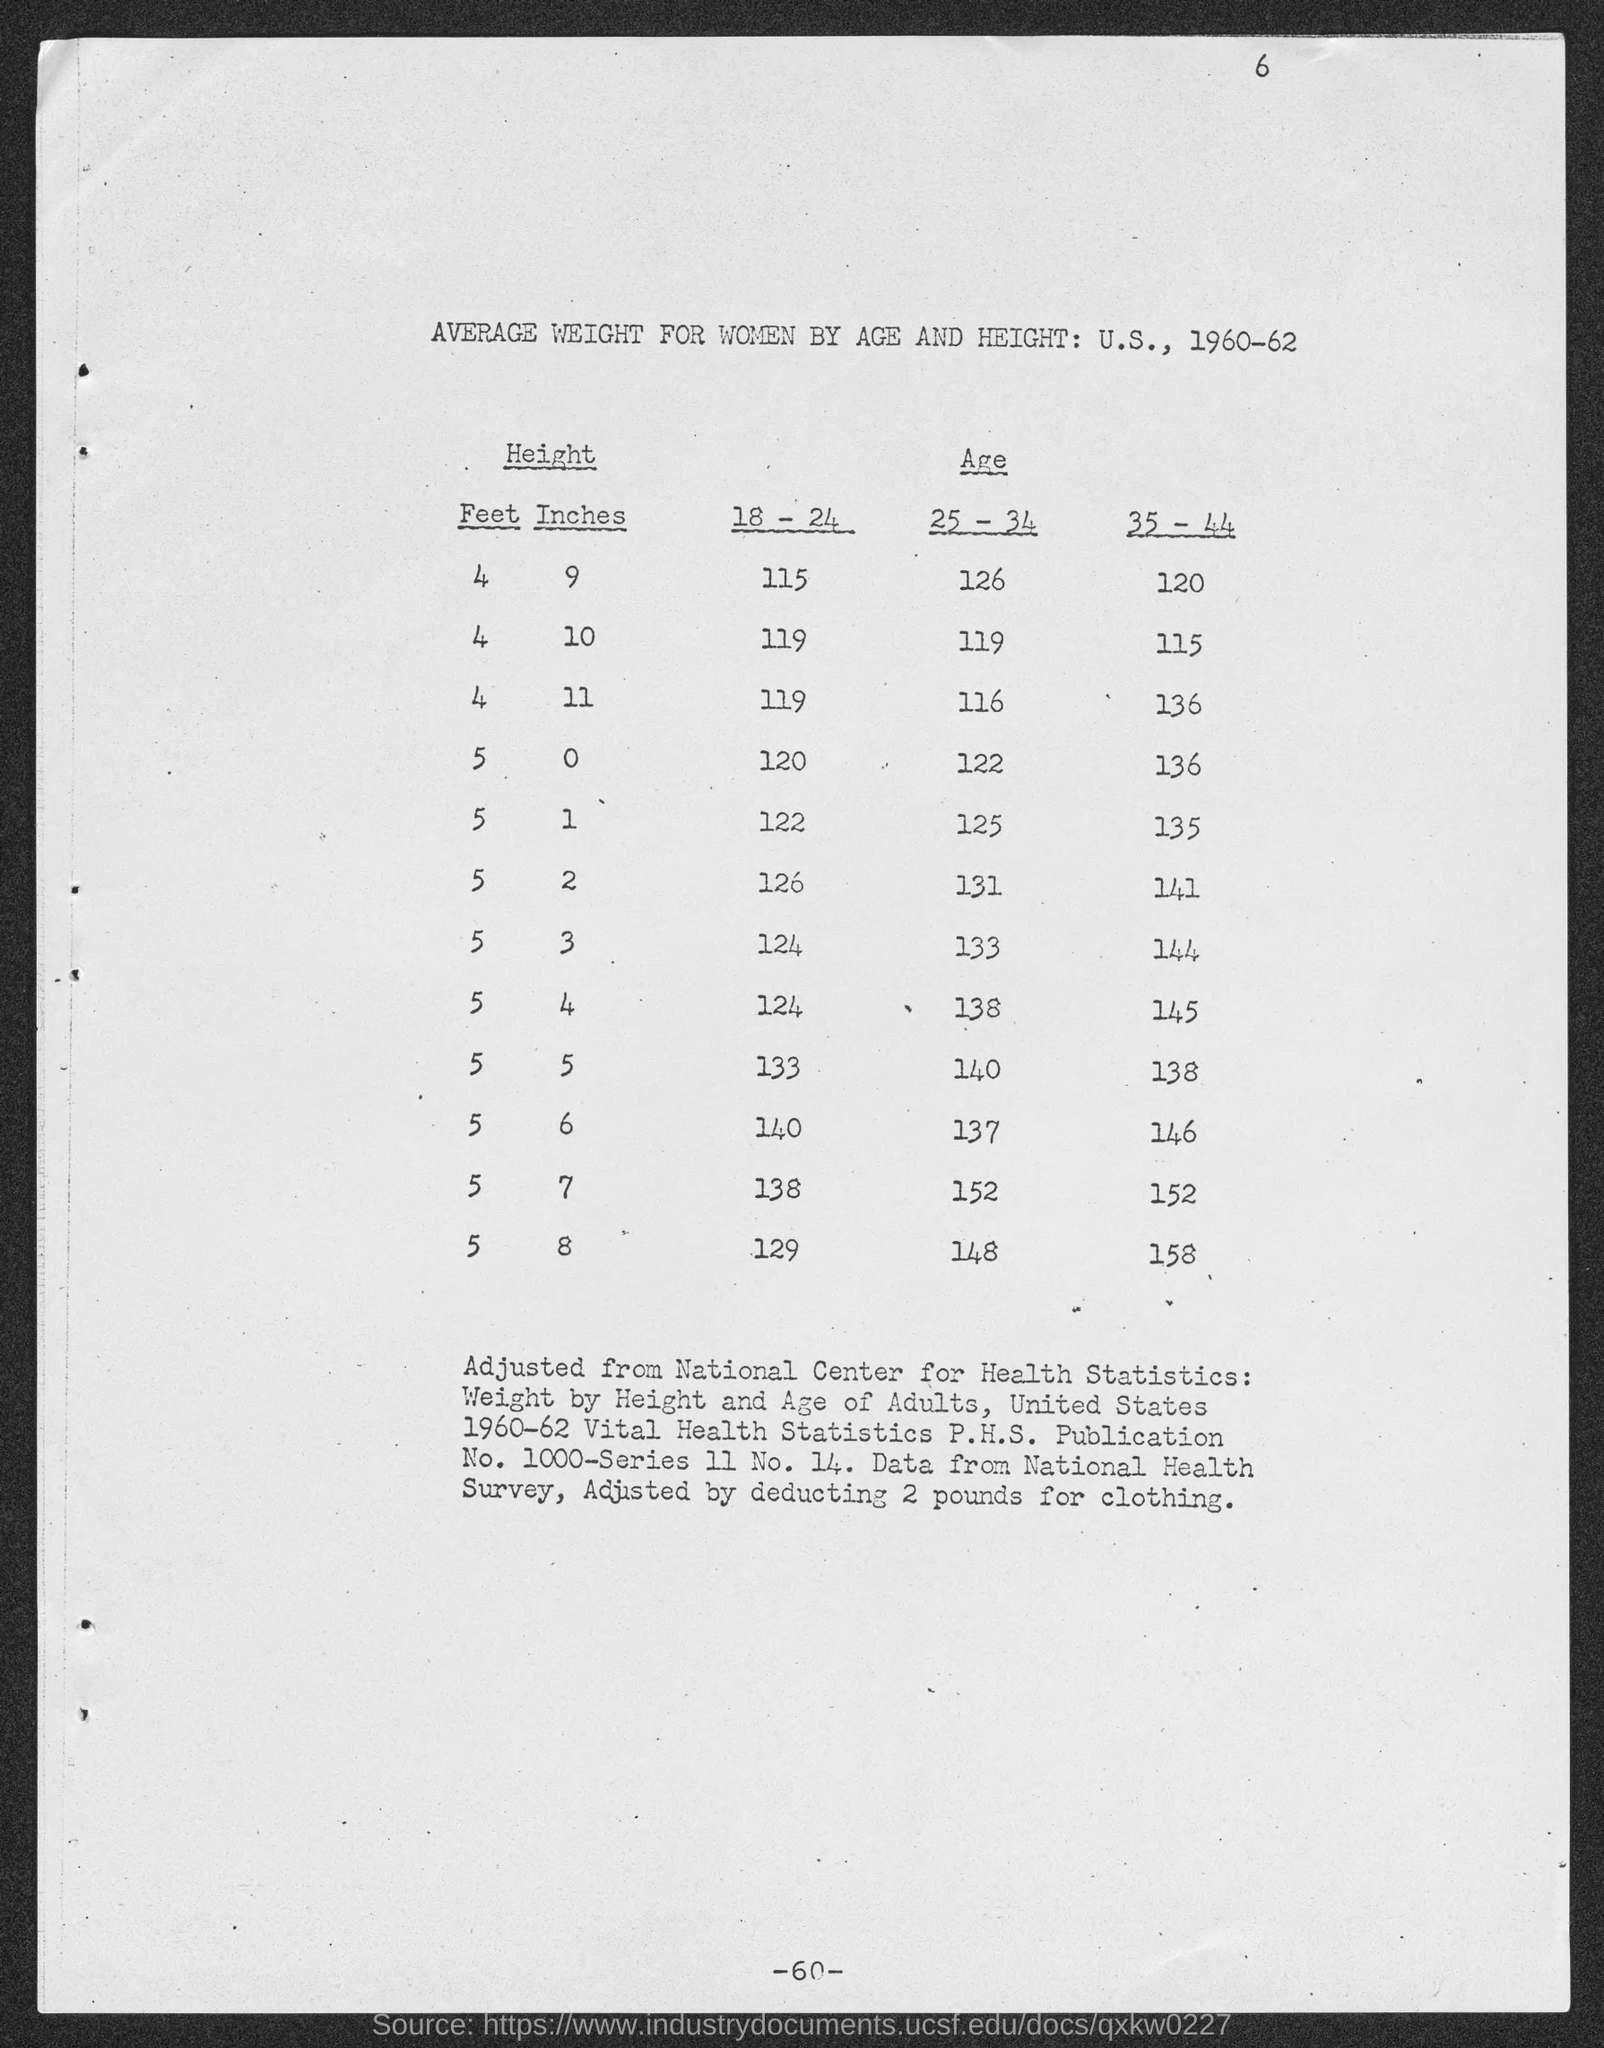What is the table title?
 Average Weight for Women by Age and Height: U.S., 1960-62 